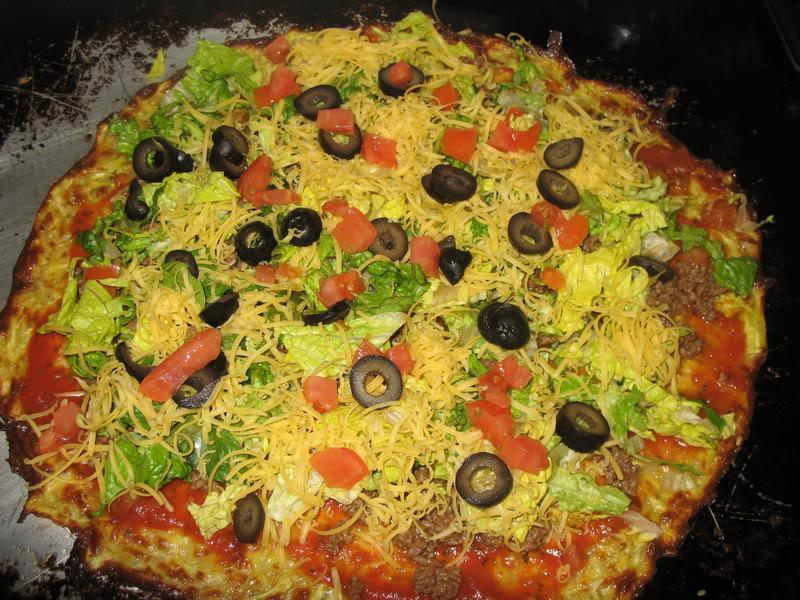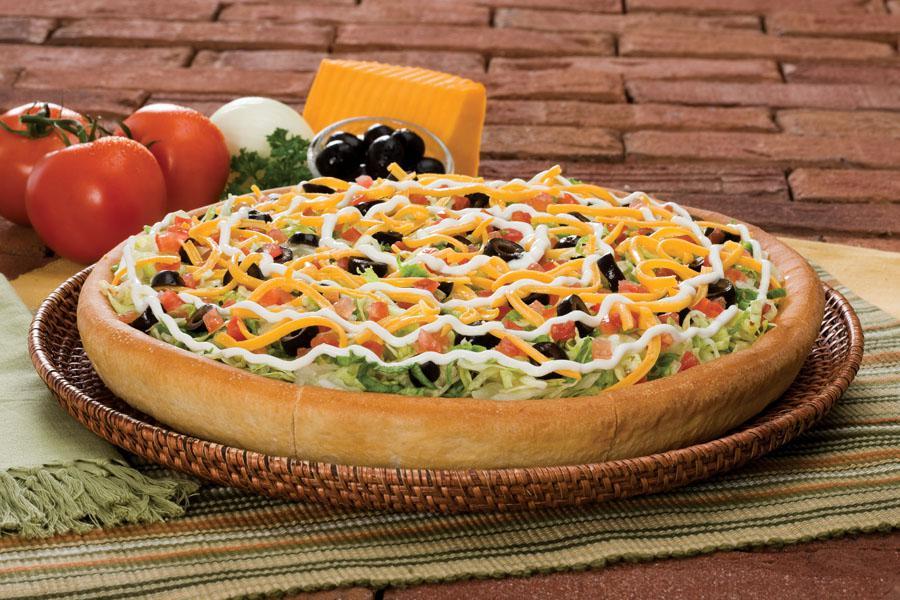The first image is the image on the left, the second image is the image on the right. Given the left and right images, does the statement "There are two round full pizzas." hold true? Answer yes or no. Yes. The first image is the image on the left, the second image is the image on the right. Considering the images on both sides, is "At least one of the pizzas has sliced olives on it." valid? Answer yes or no. Yes. 